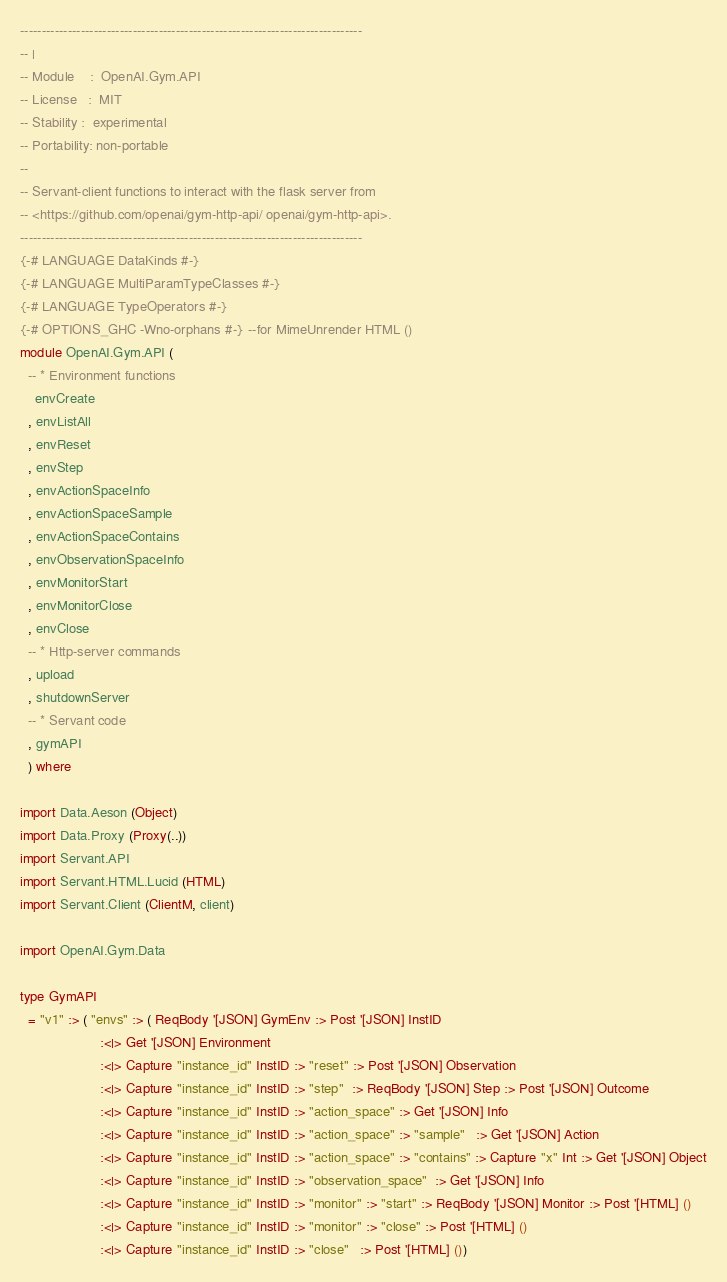<code> <loc_0><loc_0><loc_500><loc_500><_Haskell_>-------------------------------------------------------------------------------
-- |
-- Module    :  OpenAI.Gym.API
-- License   :  MIT
-- Stability :  experimental
-- Portability: non-portable
--
-- Servant-client functions to interact with the flask server from
-- <https://github.com/openai/gym-http-api/ openai/gym-http-api>.
-------------------------------------------------------------------------------
{-# LANGUAGE DataKinds #-}
{-# LANGUAGE MultiParamTypeClasses #-}
{-# LANGUAGE TypeOperators #-}
{-# OPTIONS_GHC -Wno-orphans #-} --for MimeUnrender HTML ()
module OpenAI.Gym.API (
  -- * Environment functions
    envCreate
  , envListAll
  , envReset
  , envStep
  , envActionSpaceInfo
  , envActionSpaceSample
  , envActionSpaceContains
  , envObservationSpaceInfo
  , envMonitorStart
  , envMonitorClose
  , envClose
  -- * Http-server commands
  , upload
  , shutdownServer
  -- * Servant code
  , gymAPI
  ) where

import Data.Aeson (Object)
import Data.Proxy (Proxy(..))
import Servant.API
import Servant.HTML.Lucid (HTML)
import Servant.Client (ClientM, client)

import OpenAI.Gym.Data

type GymAPI
  = "v1" :> ( "envs" :> ( ReqBody '[JSON] GymEnv :> Post '[JSON] InstID
                     :<|> Get '[JSON] Environment
                     :<|> Capture "instance_id" InstID :> "reset" :> Post '[JSON] Observation
                     :<|> Capture "instance_id" InstID :> "step"  :> ReqBody '[JSON] Step :> Post '[JSON] Outcome
                     :<|> Capture "instance_id" InstID :> "action_space" :> Get '[JSON] Info
                     :<|> Capture "instance_id" InstID :> "action_space" :> "sample"   :> Get '[JSON] Action
                     :<|> Capture "instance_id" InstID :> "action_space" :> "contains" :> Capture "x" Int :> Get '[JSON] Object
                     :<|> Capture "instance_id" InstID :> "observation_space"  :> Get '[JSON] Info
                     :<|> Capture "instance_id" InstID :> "monitor" :> "start" :> ReqBody '[JSON] Monitor :> Post '[HTML] ()
                     :<|> Capture "instance_id" InstID :> "monitor" :> "close" :> Post '[HTML] ()
                     :<|> Capture "instance_id" InstID :> "close"   :> Post '[HTML] ())</code> 